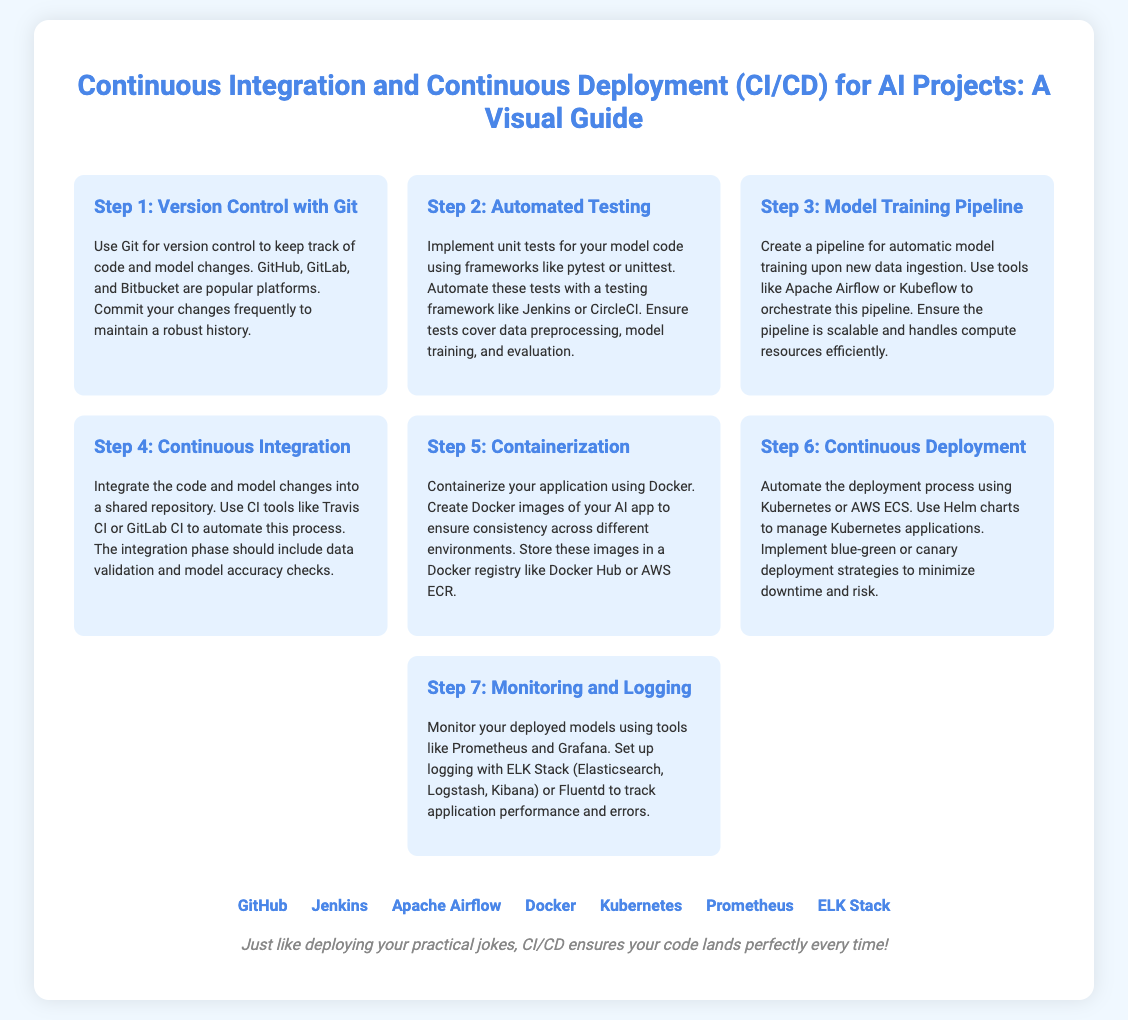what is the first step in the CI/CD process? The first step described in the document is "Version Control with Git."
Answer: Version Control with Git what tools are suggested for automated testing? The document lists frameworks like pytest or unittest for testing.
Answer: pytest or unittest which deployment strategy is mentioned for minimizing downtime? The document refers to blue-green or canary deployment strategies.
Answer: blue-green or canary how many steps are there in the CI/CD process for AI projects? There are seven steps outlined in the infographic.
Answer: seven what is used for containerization in the CI/CD process? The document states to use Docker for containerization of the application.
Answer: Docker what tool is suggested for monitoring deployed models? Prometheus is recommended for monitoring deployed models.
Answer: Prometheus which cloud service is mentioned for container orchestration? The document mentions AWS ECS as a cloud service for deployment.
Answer: AWS ECS what is the color theme used for the step titles? The color theme for the step titles is a shade of blue (4a86e8).
Answer: blue (4a86e8) 